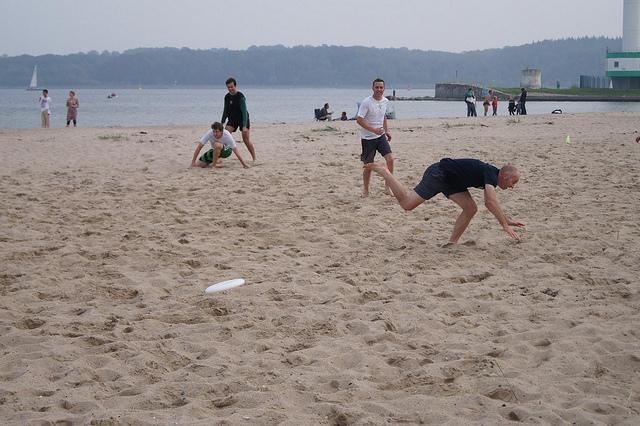How many people can you see?
Give a very brief answer. 2. 